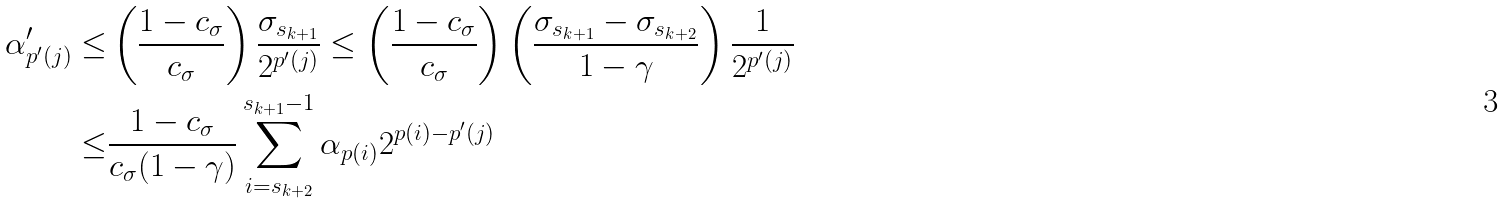<formula> <loc_0><loc_0><loc_500><loc_500>\alpha ^ { \prime } _ { p ^ { \prime } ( j ) } \leq & \left ( \frac { 1 - c _ { \sigma } } { c _ { \sigma } } \right ) \frac { \sigma _ { s _ { k + 1 } } } { 2 ^ { p ^ { \prime } ( j ) } } \leq \left ( \frac { 1 - c _ { \sigma } } { c _ { \sigma } } \right ) \left ( \frac { \sigma _ { s _ { k + 1 } } - \sigma _ { s _ { k + 2 } } } { 1 - \gamma } \right ) \frac { 1 } { 2 ^ { p ^ { \prime } ( j ) } } \\ \leq & \frac { 1 - c _ { \sigma } } { c _ { \sigma } ( 1 - \gamma ) } \sum _ { i = s _ { k + 2 } } ^ { s _ { k + 1 } - 1 } \alpha _ { p ( i ) } 2 ^ { p ( i ) - p ^ { \prime } ( j ) } \\</formula> 